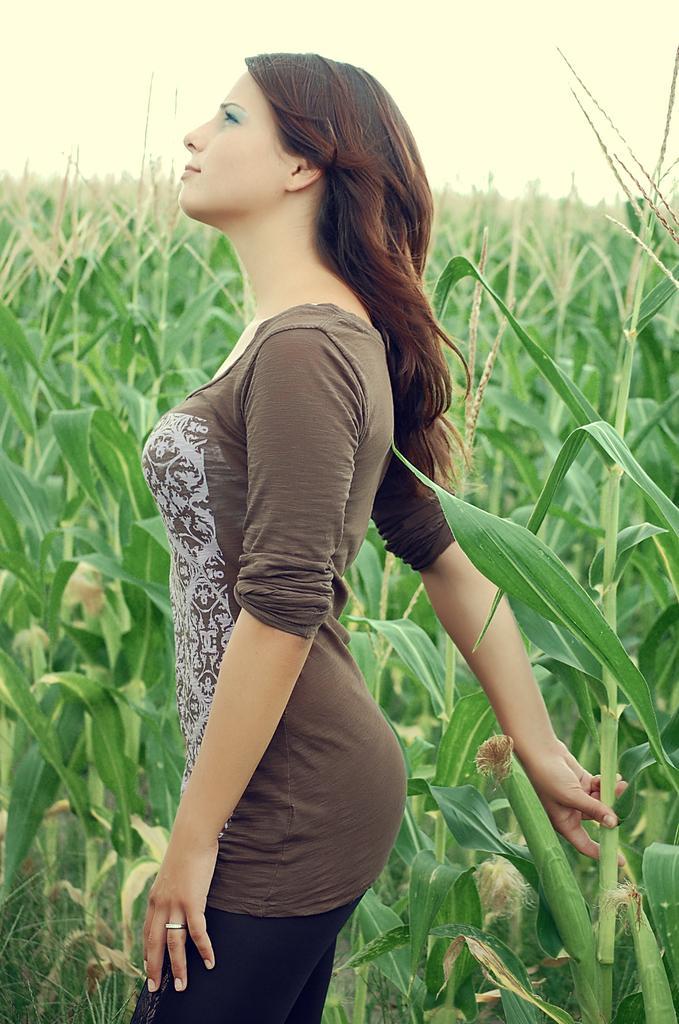Please provide a concise description of this image. In the center of this picture we can see a woman wearing t-shirt, holding a stem and standing. In the background we can see the sky and the plants. 